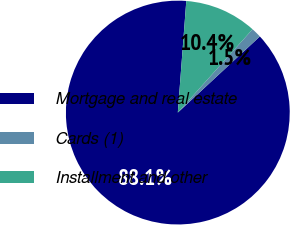<chart> <loc_0><loc_0><loc_500><loc_500><pie_chart><fcel>Mortgage and real estate<fcel>Cards (1)<fcel>Installment and other<nl><fcel>88.11%<fcel>1.46%<fcel>10.43%<nl></chart> 